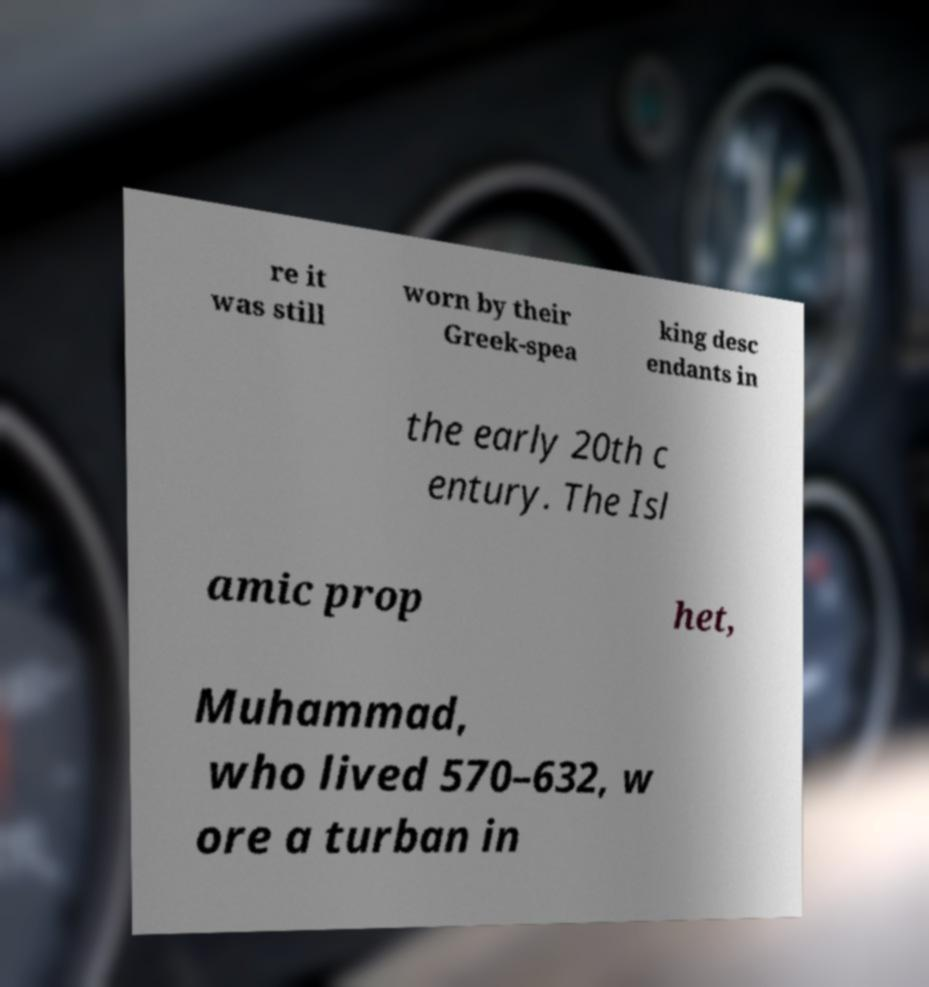Can you accurately transcribe the text from the provided image for me? re it was still worn by their Greek-spea king desc endants in the early 20th c entury. The Isl amic prop het, Muhammad, who lived 570–632, w ore a turban in 